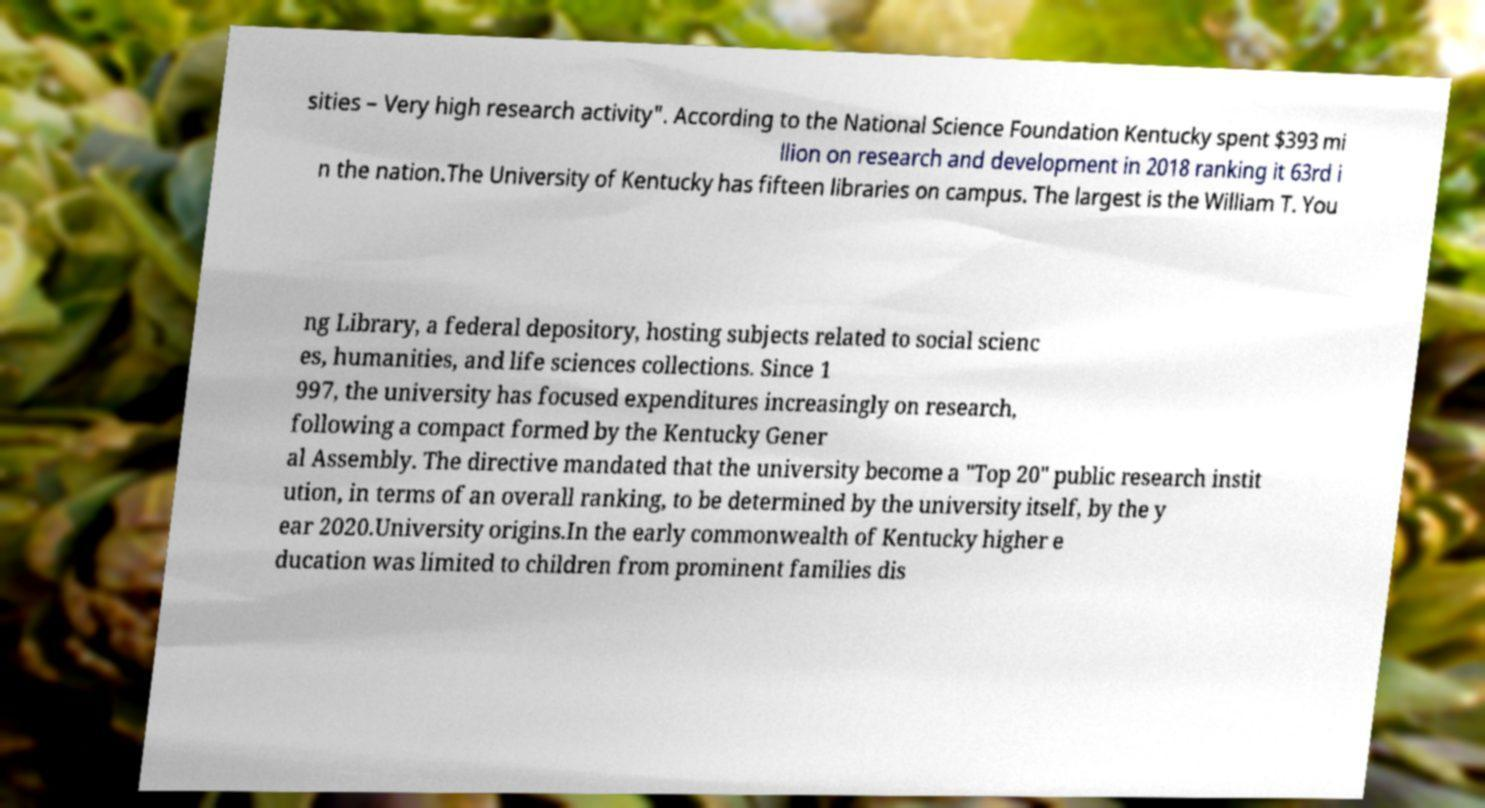Can you read and provide the text displayed in the image?This photo seems to have some interesting text. Can you extract and type it out for me? sities – Very high research activity". According to the National Science Foundation Kentucky spent $393 mi llion on research and development in 2018 ranking it 63rd i n the nation.The University of Kentucky has fifteen libraries on campus. The largest is the William T. You ng Library, a federal depository, hosting subjects related to social scienc es, humanities, and life sciences collections. Since 1 997, the university has focused expenditures increasingly on research, following a compact formed by the Kentucky Gener al Assembly. The directive mandated that the university become a "Top 20" public research instit ution, in terms of an overall ranking, to be determined by the university itself, by the y ear 2020.University origins.In the early commonwealth of Kentucky higher e ducation was limited to children from prominent families dis 